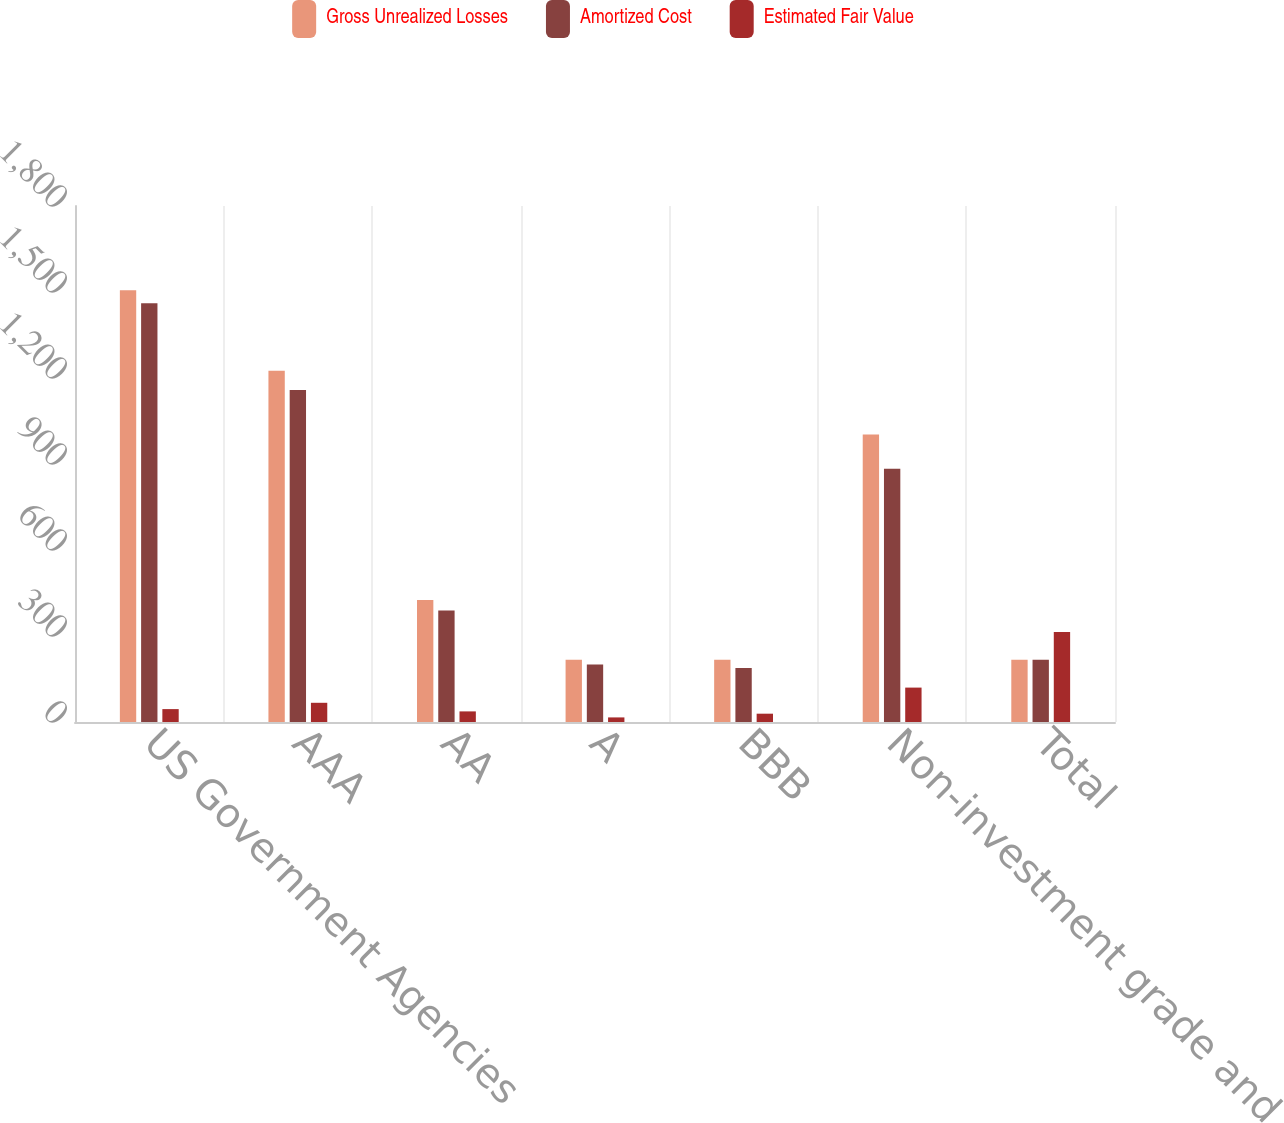Convert chart to OTSL. <chart><loc_0><loc_0><loc_500><loc_500><stacked_bar_chart><ecel><fcel>US Government Agencies<fcel>AAA<fcel>AA<fcel>A<fcel>BBB<fcel>Non-investment grade and<fcel>Total<nl><fcel>Gross Unrealized Losses<fcel>1506<fcel>1225<fcel>426<fcel>217<fcel>217<fcel>1003<fcel>217<nl><fcel>Amortized Cost<fcel>1461<fcel>1158<fcel>389<fcel>201<fcel>188<fcel>883<fcel>217<nl><fcel>Estimated Fair Value<fcel>45<fcel>67<fcel>37<fcel>16<fcel>29<fcel>120<fcel>314<nl></chart> 